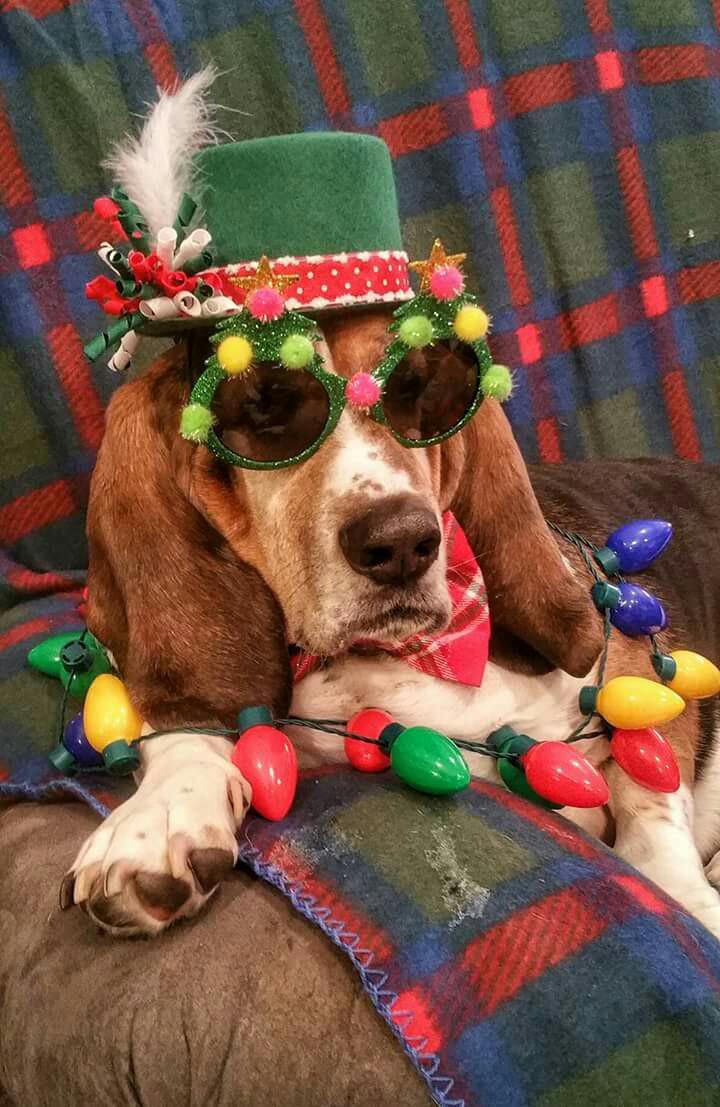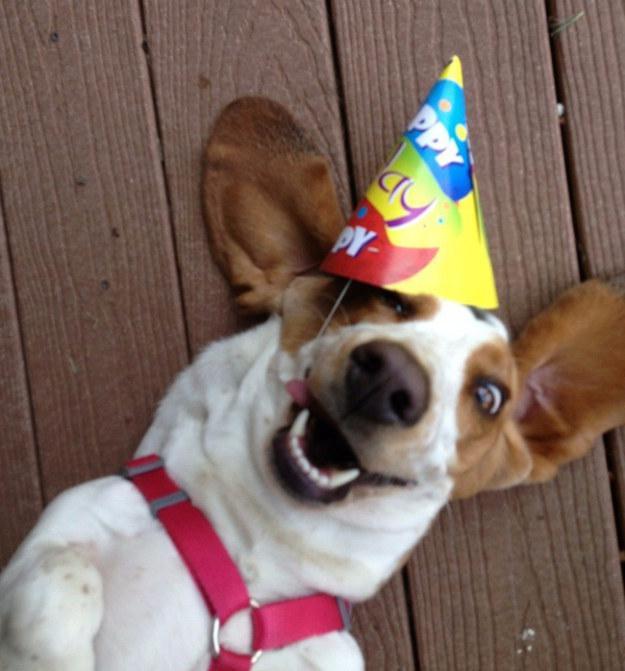The first image is the image on the left, the second image is the image on the right. For the images displayed, is the sentence "There are two basset hounds facing forward in both images." factually correct? Answer yes or no. No. The first image is the image on the left, the second image is the image on the right. Evaluate the accuracy of this statement regarding the images: "One of the dogs is lying on a couch.". Is it true? Answer yes or no. Yes. 